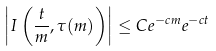Convert formula to latex. <formula><loc_0><loc_0><loc_500><loc_500>\left | I \left ( \frac { t } { m } , \tau ( m ) \right ) \right | \leq C e ^ { - c m } e ^ { - c t }</formula> 